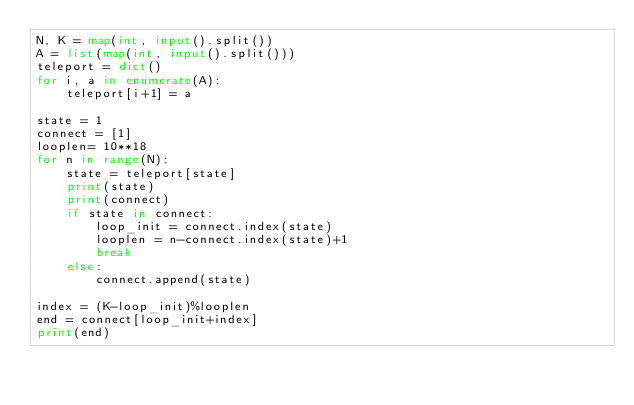Convert code to text. <code><loc_0><loc_0><loc_500><loc_500><_Python_>N, K = map(int, input().split())
A = list(map(int, input().split()))
teleport = dict()
for i, a in enumerate(A):
    teleport[i+1] = a

state = 1
connect = [1]
looplen= 10**18
for n in range(N):
    state = teleport[state] 
    print(state)
    print(connect)
    if state in connect:
        loop_init = connect.index(state)
        looplen = n-connect.index(state)+1
        break
    else:
        connect.append(state)
        
index = (K-loop_init)%looplen
end = connect[loop_init+index]
print(end)</code> 